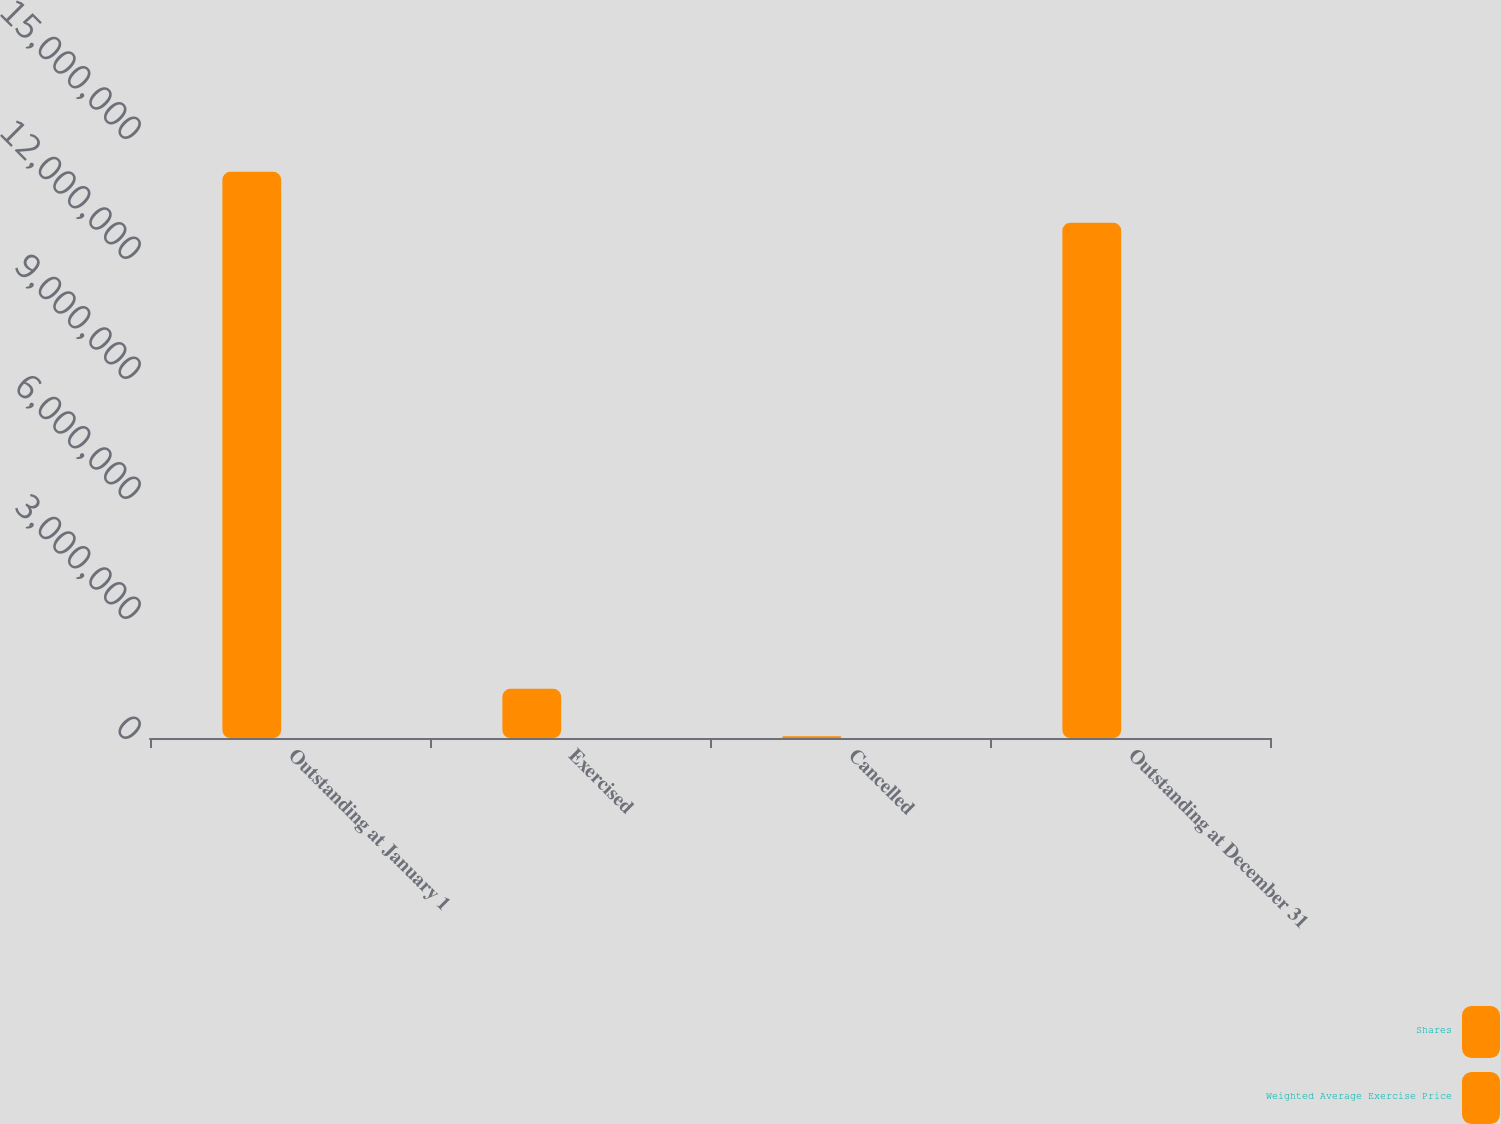Convert chart. <chart><loc_0><loc_0><loc_500><loc_500><stacked_bar_chart><ecel><fcel>Outstanding at January 1<fcel>Exercised<fcel>Cancelled<fcel>Outstanding at December 31<nl><fcel>Shares<fcel>1.41536e+07<fcel>1.22864e+06<fcel>42932<fcel>1.2882e+07<nl><fcel>Weighted Average Exercise Price<fcel>35.84<fcel>40.43<fcel>41.39<fcel>35.17<nl></chart> 